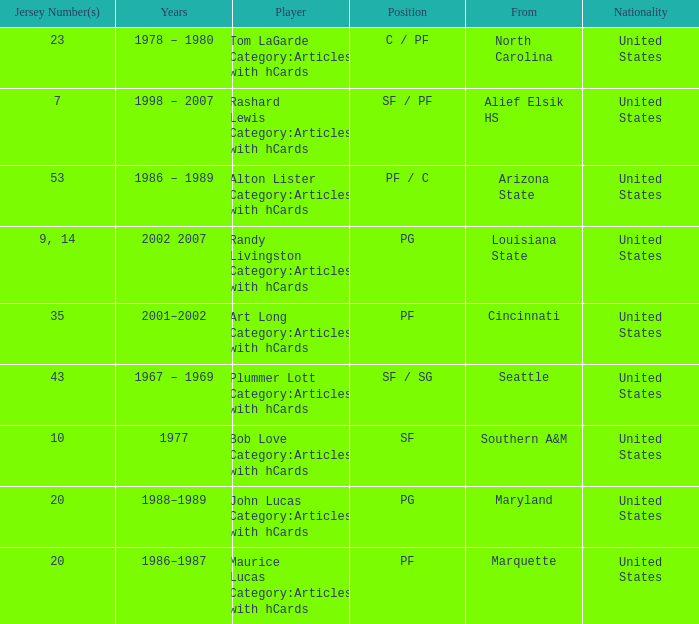Tom Lagarde Category:Articles with hCards used what Jersey Number(s)? 23.0. 